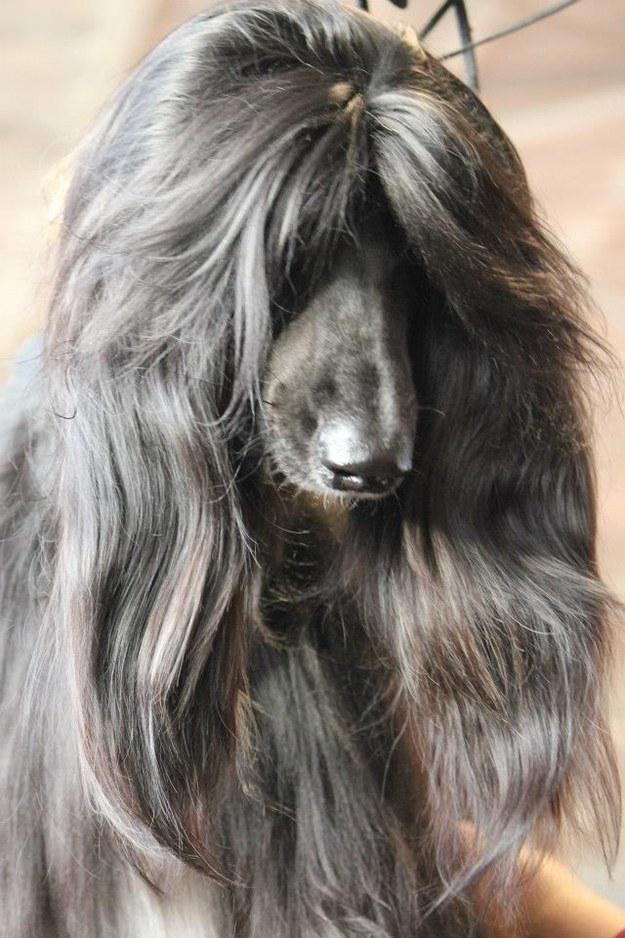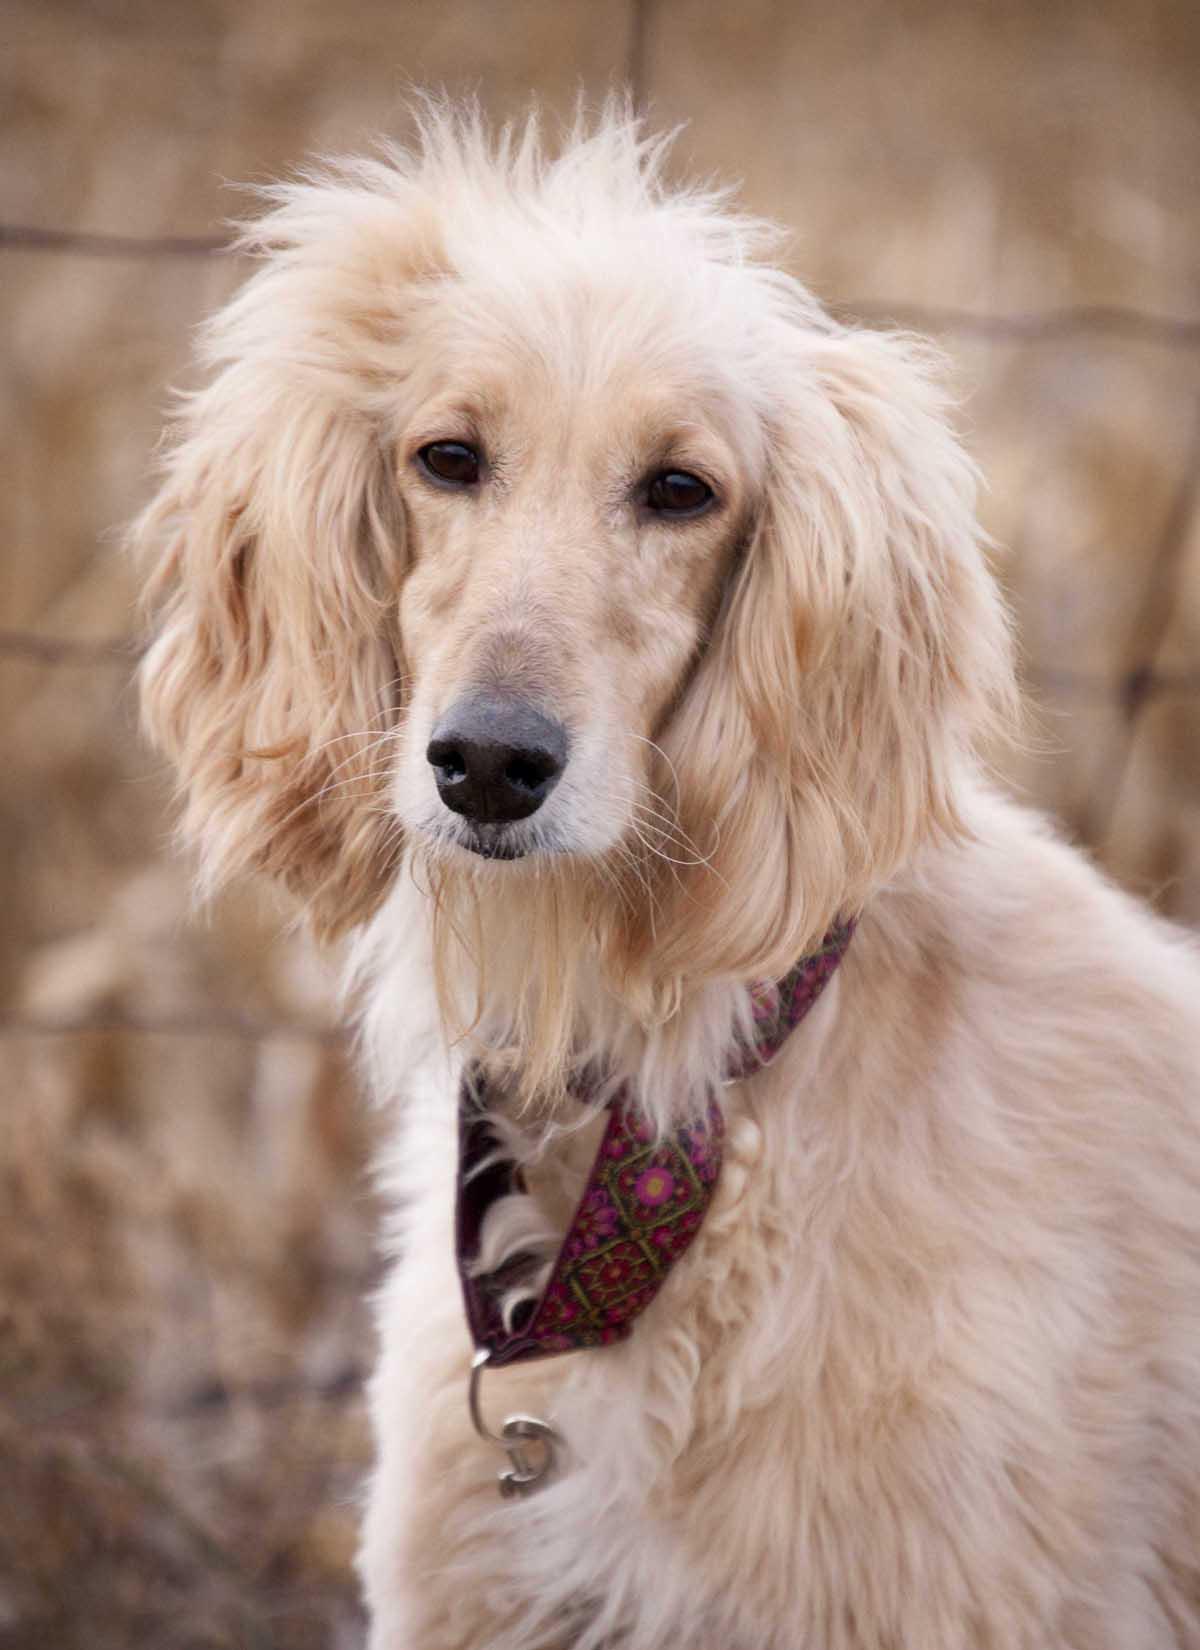The first image is the image on the left, the second image is the image on the right. Given the left and right images, does the statement "The dog in the image in the left has its mouth open." hold true? Answer yes or no. No. The first image is the image on the left, the second image is the image on the right. Assess this claim about the two images: "One image features an afghan hound with long gray hair on its head that looks like a woman's wig, and the other image features an afghan hound with a very different look.". Correct or not? Answer yes or no. Yes. 